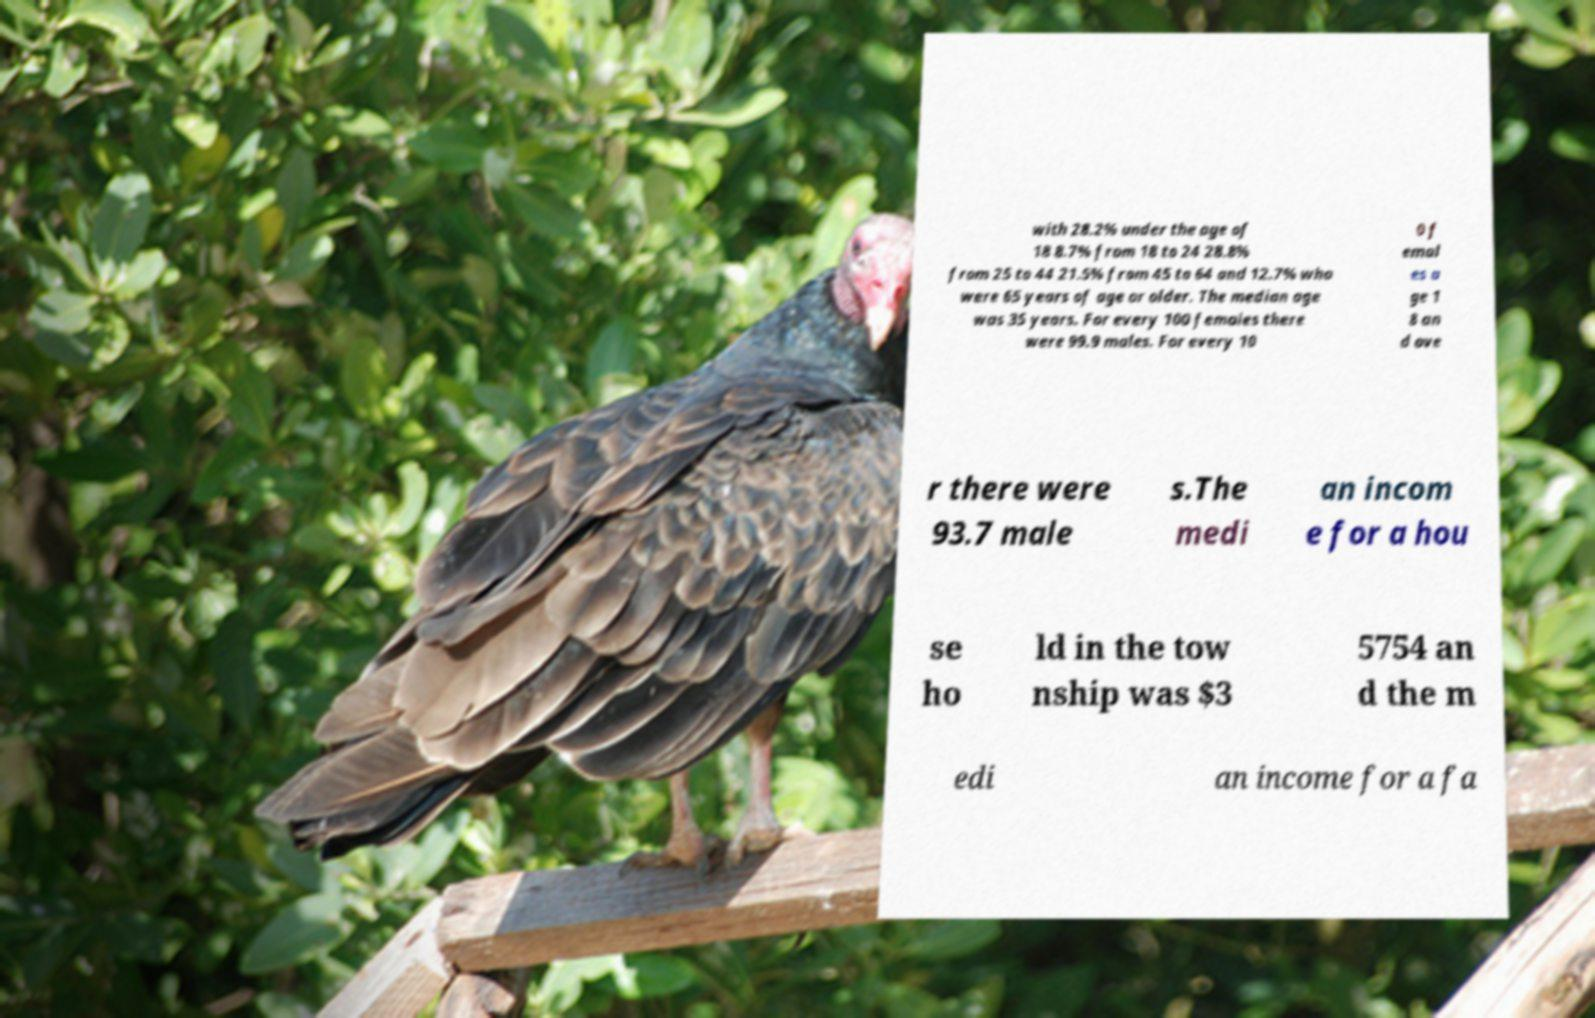What messages or text are displayed in this image? I need them in a readable, typed format. with 28.2% under the age of 18 8.7% from 18 to 24 28.8% from 25 to 44 21.5% from 45 to 64 and 12.7% who were 65 years of age or older. The median age was 35 years. For every 100 females there were 99.9 males. For every 10 0 f emal es a ge 1 8 an d ove r there were 93.7 male s.The medi an incom e for a hou se ho ld in the tow nship was $3 5754 an d the m edi an income for a fa 